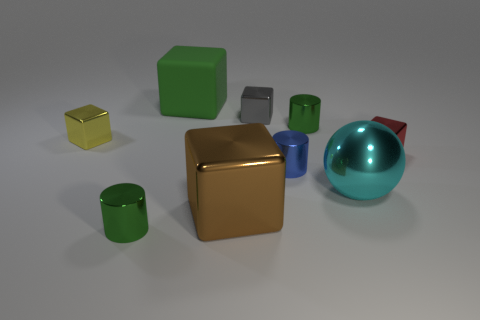There is a small gray object; are there any blue metal cylinders left of it? Observing the image, the small gray object appears to be a cube, and to the left of it, there are no blue metal cylinders. The cylinders present are green and a reflective silver color. 